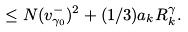Convert formula to latex. <formula><loc_0><loc_0><loc_500><loc_500>\leq N ( v _ { \gamma _ { 0 } } ^ { - } ) ^ { 2 } + ( 1 / 3 ) a _ { k } R ^ { \gamma } _ { k } .</formula> 